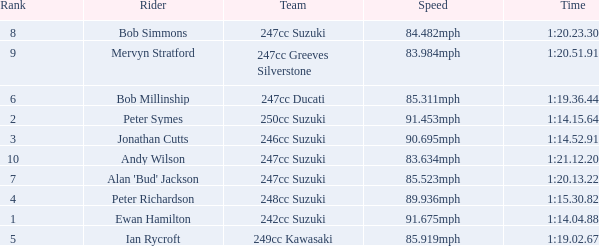What was the speed for the rider with a time of 1:14.15.64? 91.453mph. 